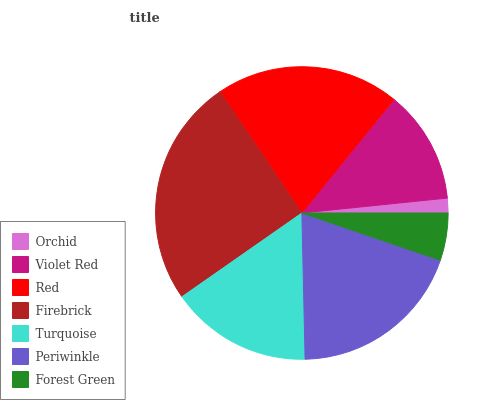Is Orchid the minimum?
Answer yes or no. Yes. Is Firebrick the maximum?
Answer yes or no. Yes. Is Violet Red the minimum?
Answer yes or no. No. Is Violet Red the maximum?
Answer yes or no. No. Is Violet Red greater than Orchid?
Answer yes or no. Yes. Is Orchid less than Violet Red?
Answer yes or no. Yes. Is Orchid greater than Violet Red?
Answer yes or no. No. Is Violet Red less than Orchid?
Answer yes or no. No. Is Turquoise the high median?
Answer yes or no. Yes. Is Turquoise the low median?
Answer yes or no. Yes. Is Red the high median?
Answer yes or no. No. Is Forest Green the low median?
Answer yes or no. No. 